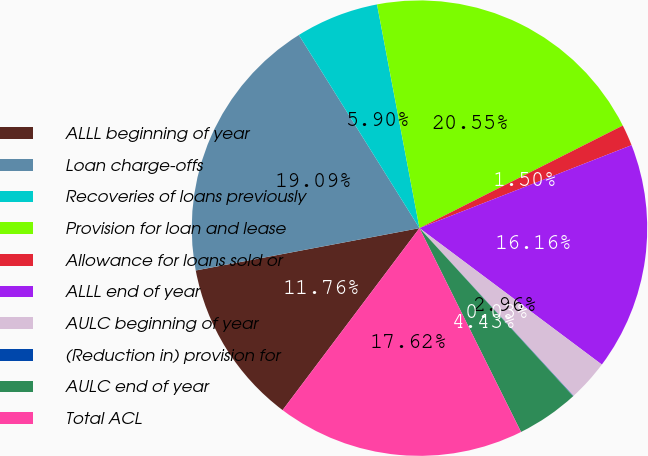Convert chart. <chart><loc_0><loc_0><loc_500><loc_500><pie_chart><fcel>ALLL beginning of year<fcel>Loan charge-offs<fcel>Recoveries of loans previously<fcel>Provision for loan and lease<fcel>Allowance for loans sold or<fcel>ALLL end of year<fcel>AULC beginning of year<fcel>(Reduction in) provision for<fcel>AULC end of year<fcel>Total ACL<nl><fcel>11.76%<fcel>19.09%<fcel>5.9%<fcel>20.55%<fcel>1.5%<fcel>16.16%<fcel>2.96%<fcel>0.03%<fcel>4.43%<fcel>17.62%<nl></chart> 